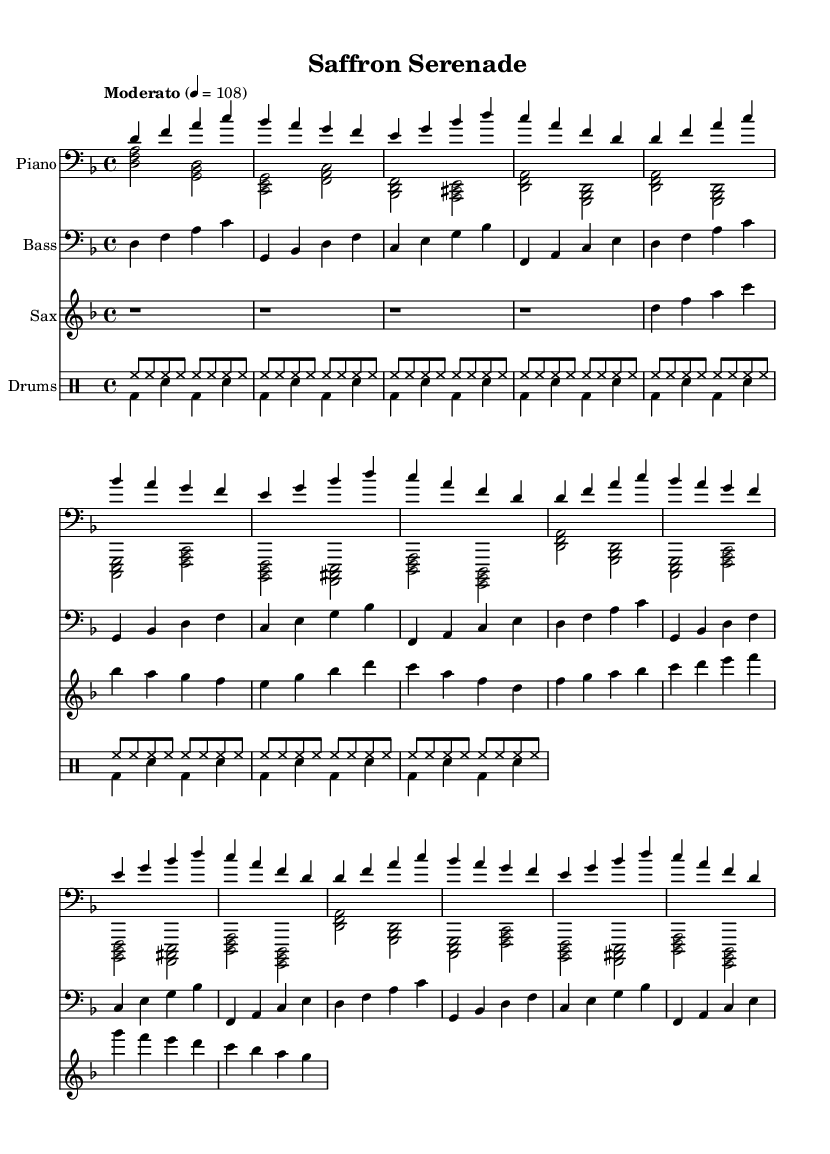What is the key signature of this music? The key signature shows a B flat and an E flat, indicating that the key is D minor.
Answer: D minor What is the time signature of this music? The time signature is indicated at the beginning of the score, showing 4/4, which means there are four beats per measure.
Answer: 4/4 What is the tempo marking of this piece? The tempo marking states "Moderato," which usually indicates a moderate speed, with a metronome marking of 108 beats per minute.
Answer: Moderato How many measures of piano right hand music are repeated? By counting the right-hand piano part, there is a section repeated three times after the initial statement.
Answer: 3 What instruments are included in this composition? Looking at the staff headers, the instruments listed are Piano, Bass, Saxophone, and Drums.
Answer: Piano, Bass, Saxophone, Drums What dynamic level is indicated for the saxophone part? The saxophone part does not have any specific dynamic markings indicated, implying it should be played at a moderate level, unless otherwise noted.
Answer: None What unique element characterizes this piece as jazz-fusion? The use of complex chords and improvisational saxophone lines suggests a blend of different musical styles inherent to jazz-fusion.
Answer: Complex chords and improvisation 